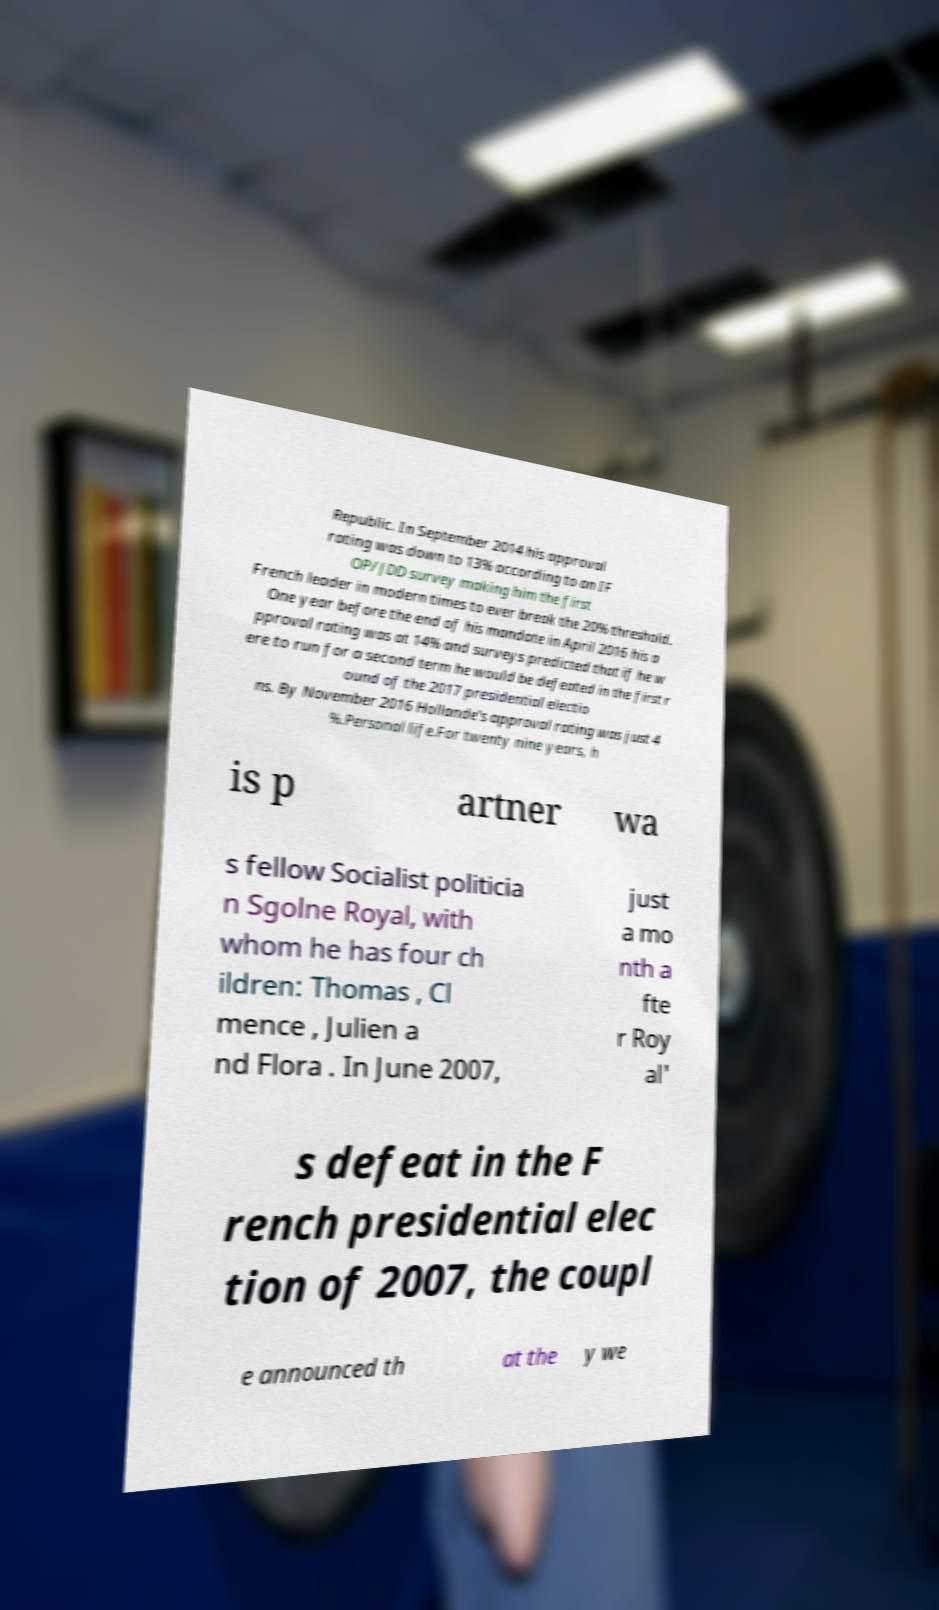Could you assist in decoding the text presented in this image and type it out clearly? Republic. In September 2014 his approval rating was down to 13% according to an IF OP/JDD survey making him the first French leader in modern times to ever break the 20% threshold. One year before the end of his mandate in April 2016 his a pproval rating was at 14% and surveys predicted that if he w ere to run for a second term he would be defeated in the first r ound of the 2017 presidential electio ns. By November 2016 Hollande's approval rating was just 4 %.Personal life.For twenty nine years, h is p artner wa s fellow Socialist politicia n Sgolne Royal, with whom he has four ch ildren: Thomas , Cl mence , Julien a nd Flora . In June 2007, just a mo nth a fte r Roy al' s defeat in the F rench presidential elec tion of 2007, the coupl e announced th at the y we 